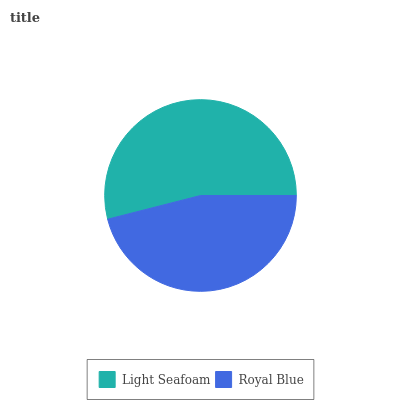Is Royal Blue the minimum?
Answer yes or no. Yes. Is Light Seafoam the maximum?
Answer yes or no. Yes. Is Royal Blue the maximum?
Answer yes or no. No. Is Light Seafoam greater than Royal Blue?
Answer yes or no. Yes. Is Royal Blue less than Light Seafoam?
Answer yes or no. Yes. Is Royal Blue greater than Light Seafoam?
Answer yes or no. No. Is Light Seafoam less than Royal Blue?
Answer yes or no. No. Is Light Seafoam the high median?
Answer yes or no. Yes. Is Royal Blue the low median?
Answer yes or no. Yes. Is Royal Blue the high median?
Answer yes or no. No. Is Light Seafoam the low median?
Answer yes or no. No. 